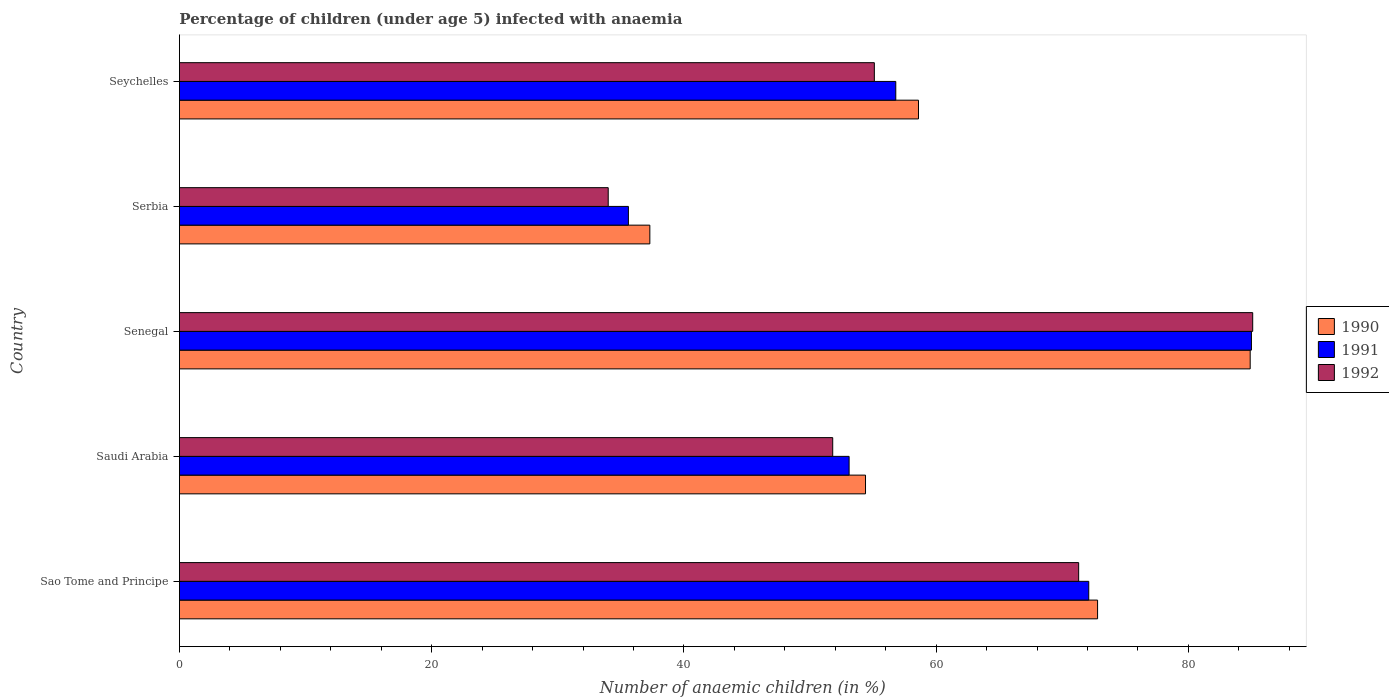How many different coloured bars are there?
Make the answer very short. 3. Are the number of bars per tick equal to the number of legend labels?
Keep it short and to the point. Yes. What is the label of the 3rd group of bars from the top?
Offer a very short reply. Senegal. What is the percentage of children infected with anaemia in in 1992 in Seychelles?
Give a very brief answer. 55.1. Across all countries, what is the maximum percentage of children infected with anaemia in in 1990?
Your answer should be compact. 84.9. Across all countries, what is the minimum percentage of children infected with anaemia in in 1990?
Keep it short and to the point. 37.3. In which country was the percentage of children infected with anaemia in in 1990 maximum?
Give a very brief answer. Senegal. In which country was the percentage of children infected with anaemia in in 1991 minimum?
Offer a very short reply. Serbia. What is the total percentage of children infected with anaemia in in 1992 in the graph?
Give a very brief answer. 297.3. What is the difference between the percentage of children infected with anaemia in in 1990 in Sao Tome and Principe and that in Senegal?
Provide a succinct answer. -12.1. What is the average percentage of children infected with anaemia in in 1990 per country?
Ensure brevity in your answer.  61.6. What is the difference between the percentage of children infected with anaemia in in 1991 and percentage of children infected with anaemia in in 1990 in Serbia?
Your answer should be very brief. -1.7. What is the ratio of the percentage of children infected with anaemia in in 1990 in Saudi Arabia to that in Serbia?
Provide a short and direct response. 1.46. What is the difference between the highest and the second highest percentage of children infected with anaemia in in 1990?
Your response must be concise. 12.1. What is the difference between the highest and the lowest percentage of children infected with anaemia in in 1990?
Provide a succinct answer. 47.6. What does the 3rd bar from the bottom in Sao Tome and Principe represents?
Your answer should be compact. 1992. Are all the bars in the graph horizontal?
Your answer should be very brief. Yes. Are the values on the major ticks of X-axis written in scientific E-notation?
Your answer should be very brief. No. Does the graph contain any zero values?
Provide a short and direct response. No. Where does the legend appear in the graph?
Provide a short and direct response. Center right. What is the title of the graph?
Your answer should be very brief. Percentage of children (under age 5) infected with anaemia. Does "1991" appear as one of the legend labels in the graph?
Offer a very short reply. Yes. What is the label or title of the X-axis?
Ensure brevity in your answer.  Number of anaemic children (in %). What is the label or title of the Y-axis?
Make the answer very short. Country. What is the Number of anaemic children (in %) in 1990 in Sao Tome and Principe?
Keep it short and to the point. 72.8. What is the Number of anaemic children (in %) of 1991 in Sao Tome and Principe?
Ensure brevity in your answer.  72.1. What is the Number of anaemic children (in %) in 1992 in Sao Tome and Principe?
Your response must be concise. 71.3. What is the Number of anaemic children (in %) of 1990 in Saudi Arabia?
Your answer should be very brief. 54.4. What is the Number of anaemic children (in %) in 1991 in Saudi Arabia?
Provide a succinct answer. 53.1. What is the Number of anaemic children (in %) in 1992 in Saudi Arabia?
Provide a short and direct response. 51.8. What is the Number of anaemic children (in %) in 1990 in Senegal?
Your answer should be very brief. 84.9. What is the Number of anaemic children (in %) of 1992 in Senegal?
Your answer should be very brief. 85.1. What is the Number of anaemic children (in %) in 1990 in Serbia?
Give a very brief answer. 37.3. What is the Number of anaemic children (in %) of 1991 in Serbia?
Offer a terse response. 35.6. What is the Number of anaemic children (in %) in 1990 in Seychelles?
Keep it short and to the point. 58.6. What is the Number of anaemic children (in %) in 1991 in Seychelles?
Your answer should be very brief. 56.8. What is the Number of anaemic children (in %) in 1992 in Seychelles?
Give a very brief answer. 55.1. Across all countries, what is the maximum Number of anaemic children (in %) of 1990?
Ensure brevity in your answer.  84.9. Across all countries, what is the maximum Number of anaemic children (in %) of 1992?
Give a very brief answer. 85.1. Across all countries, what is the minimum Number of anaemic children (in %) of 1990?
Provide a succinct answer. 37.3. Across all countries, what is the minimum Number of anaemic children (in %) of 1991?
Offer a terse response. 35.6. What is the total Number of anaemic children (in %) in 1990 in the graph?
Offer a very short reply. 308. What is the total Number of anaemic children (in %) of 1991 in the graph?
Provide a succinct answer. 302.6. What is the total Number of anaemic children (in %) in 1992 in the graph?
Ensure brevity in your answer.  297.3. What is the difference between the Number of anaemic children (in %) in 1991 in Sao Tome and Principe and that in Saudi Arabia?
Your answer should be compact. 19. What is the difference between the Number of anaemic children (in %) of 1990 in Sao Tome and Principe and that in Serbia?
Your answer should be compact. 35.5. What is the difference between the Number of anaemic children (in %) of 1991 in Sao Tome and Principe and that in Serbia?
Provide a succinct answer. 36.5. What is the difference between the Number of anaemic children (in %) of 1992 in Sao Tome and Principe and that in Serbia?
Offer a very short reply. 37.3. What is the difference between the Number of anaemic children (in %) of 1990 in Sao Tome and Principe and that in Seychelles?
Your answer should be compact. 14.2. What is the difference between the Number of anaemic children (in %) of 1991 in Sao Tome and Principe and that in Seychelles?
Your response must be concise. 15.3. What is the difference between the Number of anaemic children (in %) in 1990 in Saudi Arabia and that in Senegal?
Your response must be concise. -30.5. What is the difference between the Number of anaemic children (in %) of 1991 in Saudi Arabia and that in Senegal?
Your answer should be very brief. -31.9. What is the difference between the Number of anaemic children (in %) in 1992 in Saudi Arabia and that in Senegal?
Make the answer very short. -33.3. What is the difference between the Number of anaemic children (in %) in 1990 in Saudi Arabia and that in Serbia?
Your response must be concise. 17.1. What is the difference between the Number of anaemic children (in %) of 1991 in Saudi Arabia and that in Serbia?
Ensure brevity in your answer.  17.5. What is the difference between the Number of anaemic children (in %) of 1992 in Saudi Arabia and that in Serbia?
Your answer should be very brief. 17.8. What is the difference between the Number of anaemic children (in %) of 1990 in Saudi Arabia and that in Seychelles?
Ensure brevity in your answer.  -4.2. What is the difference between the Number of anaemic children (in %) in 1991 in Saudi Arabia and that in Seychelles?
Make the answer very short. -3.7. What is the difference between the Number of anaemic children (in %) in 1990 in Senegal and that in Serbia?
Offer a terse response. 47.6. What is the difference between the Number of anaemic children (in %) of 1991 in Senegal and that in Serbia?
Offer a very short reply. 49.4. What is the difference between the Number of anaemic children (in %) of 1992 in Senegal and that in Serbia?
Your answer should be very brief. 51.1. What is the difference between the Number of anaemic children (in %) in 1990 in Senegal and that in Seychelles?
Offer a very short reply. 26.3. What is the difference between the Number of anaemic children (in %) of 1991 in Senegal and that in Seychelles?
Ensure brevity in your answer.  28.2. What is the difference between the Number of anaemic children (in %) in 1992 in Senegal and that in Seychelles?
Keep it short and to the point. 30. What is the difference between the Number of anaemic children (in %) of 1990 in Serbia and that in Seychelles?
Give a very brief answer. -21.3. What is the difference between the Number of anaemic children (in %) of 1991 in Serbia and that in Seychelles?
Provide a succinct answer. -21.2. What is the difference between the Number of anaemic children (in %) in 1992 in Serbia and that in Seychelles?
Your answer should be compact. -21.1. What is the difference between the Number of anaemic children (in %) of 1991 in Sao Tome and Principe and the Number of anaemic children (in %) of 1992 in Saudi Arabia?
Make the answer very short. 20.3. What is the difference between the Number of anaemic children (in %) of 1990 in Sao Tome and Principe and the Number of anaemic children (in %) of 1992 in Senegal?
Provide a short and direct response. -12.3. What is the difference between the Number of anaemic children (in %) of 1990 in Sao Tome and Principe and the Number of anaemic children (in %) of 1991 in Serbia?
Provide a short and direct response. 37.2. What is the difference between the Number of anaemic children (in %) of 1990 in Sao Tome and Principe and the Number of anaemic children (in %) of 1992 in Serbia?
Keep it short and to the point. 38.8. What is the difference between the Number of anaemic children (in %) in 1991 in Sao Tome and Principe and the Number of anaemic children (in %) in 1992 in Serbia?
Keep it short and to the point. 38.1. What is the difference between the Number of anaemic children (in %) in 1990 in Sao Tome and Principe and the Number of anaemic children (in %) in 1991 in Seychelles?
Make the answer very short. 16. What is the difference between the Number of anaemic children (in %) in 1991 in Sao Tome and Principe and the Number of anaemic children (in %) in 1992 in Seychelles?
Keep it short and to the point. 17. What is the difference between the Number of anaemic children (in %) of 1990 in Saudi Arabia and the Number of anaemic children (in %) of 1991 in Senegal?
Keep it short and to the point. -30.6. What is the difference between the Number of anaemic children (in %) of 1990 in Saudi Arabia and the Number of anaemic children (in %) of 1992 in Senegal?
Your response must be concise. -30.7. What is the difference between the Number of anaemic children (in %) in 1991 in Saudi Arabia and the Number of anaemic children (in %) in 1992 in Senegal?
Keep it short and to the point. -32. What is the difference between the Number of anaemic children (in %) in 1990 in Saudi Arabia and the Number of anaemic children (in %) in 1992 in Serbia?
Give a very brief answer. 20.4. What is the difference between the Number of anaemic children (in %) of 1991 in Saudi Arabia and the Number of anaemic children (in %) of 1992 in Serbia?
Offer a terse response. 19.1. What is the difference between the Number of anaemic children (in %) of 1990 in Saudi Arabia and the Number of anaemic children (in %) of 1992 in Seychelles?
Make the answer very short. -0.7. What is the difference between the Number of anaemic children (in %) of 1991 in Saudi Arabia and the Number of anaemic children (in %) of 1992 in Seychelles?
Your answer should be compact. -2. What is the difference between the Number of anaemic children (in %) of 1990 in Senegal and the Number of anaemic children (in %) of 1991 in Serbia?
Offer a very short reply. 49.3. What is the difference between the Number of anaemic children (in %) in 1990 in Senegal and the Number of anaemic children (in %) in 1992 in Serbia?
Keep it short and to the point. 50.9. What is the difference between the Number of anaemic children (in %) of 1991 in Senegal and the Number of anaemic children (in %) of 1992 in Serbia?
Keep it short and to the point. 51. What is the difference between the Number of anaemic children (in %) in 1990 in Senegal and the Number of anaemic children (in %) in 1991 in Seychelles?
Your response must be concise. 28.1. What is the difference between the Number of anaemic children (in %) in 1990 in Senegal and the Number of anaemic children (in %) in 1992 in Seychelles?
Your response must be concise. 29.8. What is the difference between the Number of anaemic children (in %) in 1991 in Senegal and the Number of anaemic children (in %) in 1992 in Seychelles?
Offer a very short reply. 29.9. What is the difference between the Number of anaemic children (in %) in 1990 in Serbia and the Number of anaemic children (in %) in 1991 in Seychelles?
Provide a succinct answer. -19.5. What is the difference between the Number of anaemic children (in %) in 1990 in Serbia and the Number of anaemic children (in %) in 1992 in Seychelles?
Your answer should be compact. -17.8. What is the difference between the Number of anaemic children (in %) of 1991 in Serbia and the Number of anaemic children (in %) of 1992 in Seychelles?
Offer a very short reply. -19.5. What is the average Number of anaemic children (in %) of 1990 per country?
Keep it short and to the point. 61.6. What is the average Number of anaemic children (in %) in 1991 per country?
Make the answer very short. 60.52. What is the average Number of anaemic children (in %) of 1992 per country?
Ensure brevity in your answer.  59.46. What is the difference between the Number of anaemic children (in %) of 1990 and Number of anaemic children (in %) of 1991 in Sao Tome and Principe?
Give a very brief answer. 0.7. What is the difference between the Number of anaemic children (in %) of 1991 and Number of anaemic children (in %) of 1992 in Sao Tome and Principe?
Provide a short and direct response. 0.8. What is the difference between the Number of anaemic children (in %) in 1990 and Number of anaemic children (in %) in 1991 in Saudi Arabia?
Offer a terse response. 1.3. What is the difference between the Number of anaemic children (in %) in 1990 and Number of anaemic children (in %) in 1992 in Saudi Arabia?
Give a very brief answer. 2.6. What is the difference between the Number of anaemic children (in %) in 1991 and Number of anaemic children (in %) in 1992 in Senegal?
Your answer should be very brief. -0.1. What is the difference between the Number of anaemic children (in %) in 1990 and Number of anaemic children (in %) in 1992 in Serbia?
Provide a succinct answer. 3.3. What is the difference between the Number of anaemic children (in %) in 1990 and Number of anaemic children (in %) in 1992 in Seychelles?
Offer a very short reply. 3.5. What is the difference between the Number of anaemic children (in %) in 1991 and Number of anaemic children (in %) in 1992 in Seychelles?
Offer a terse response. 1.7. What is the ratio of the Number of anaemic children (in %) in 1990 in Sao Tome and Principe to that in Saudi Arabia?
Make the answer very short. 1.34. What is the ratio of the Number of anaemic children (in %) of 1991 in Sao Tome and Principe to that in Saudi Arabia?
Your response must be concise. 1.36. What is the ratio of the Number of anaemic children (in %) of 1992 in Sao Tome and Principe to that in Saudi Arabia?
Your answer should be very brief. 1.38. What is the ratio of the Number of anaemic children (in %) of 1990 in Sao Tome and Principe to that in Senegal?
Provide a succinct answer. 0.86. What is the ratio of the Number of anaemic children (in %) of 1991 in Sao Tome and Principe to that in Senegal?
Your answer should be compact. 0.85. What is the ratio of the Number of anaemic children (in %) of 1992 in Sao Tome and Principe to that in Senegal?
Give a very brief answer. 0.84. What is the ratio of the Number of anaemic children (in %) in 1990 in Sao Tome and Principe to that in Serbia?
Give a very brief answer. 1.95. What is the ratio of the Number of anaemic children (in %) in 1991 in Sao Tome and Principe to that in Serbia?
Ensure brevity in your answer.  2.03. What is the ratio of the Number of anaemic children (in %) in 1992 in Sao Tome and Principe to that in Serbia?
Provide a short and direct response. 2.1. What is the ratio of the Number of anaemic children (in %) in 1990 in Sao Tome and Principe to that in Seychelles?
Ensure brevity in your answer.  1.24. What is the ratio of the Number of anaemic children (in %) of 1991 in Sao Tome and Principe to that in Seychelles?
Make the answer very short. 1.27. What is the ratio of the Number of anaemic children (in %) in 1992 in Sao Tome and Principe to that in Seychelles?
Make the answer very short. 1.29. What is the ratio of the Number of anaemic children (in %) of 1990 in Saudi Arabia to that in Senegal?
Your answer should be compact. 0.64. What is the ratio of the Number of anaemic children (in %) of 1991 in Saudi Arabia to that in Senegal?
Provide a succinct answer. 0.62. What is the ratio of the Number of anaemic children (in %) in 1992 in Saudi Arabia to that in Senegal?
Offer a terse response. 0.61. What is the ratio of the Number of anaemic children (in %) in 1990 in Saudi Arabia to that in Serbia?
Ensure brevity in your answer.  1.46. What is the ratio of the Number of anaemic children (in %) in 1991 in Saudi Arabia to that in Serbia?
Make the answer very short. 1.49. What is the ratio of the Number of anaemic children (in %) in 1992 in Saudi Arabia to that in Serbia?
Offer a terse response. 1.52. What is the ratio of the Number of anaemic children (in %) of 1990 in Saudi Arabia to that in Seychelles?
Keep it short and to the point. 0.93. What is the ratio of the Number of anaemic children (in %) in 1991 in Saudi Arabia to that in Seychelles?
Your answer should be compact. 0.93. What is the ratio of the Number of anaemic children (in %) of 1992 in Saudi Arabia to that in Seychelles?
Offer a terse response. 0.94. What is the ratio of the Number of anaemic children (in %) of 1990 in Senegal to that in Serbia?
Offer a very short reply. 2.28. What is the ratio of the Number of anaemic children (in %) of 1991 in Senegal to that in Serbia?
Offer a terse response. 2.39. What is the ratio of the Number of anaemic children (in %) of 1992 in Senegal to that in Serbia?
Provide a short and direct response. 2.5. What is the ratio of the Number of anaemic children (in %) in 1990 in Senegal to that in Seychelles?
Your answer should be very brief. 1.45. What is the ratio of the Number of anaemic children (in %) of 1991 in Senegal to that in Seychelles?
Your answer should be compact. 1.5. What is the ratio of the Number of anaemic children (in %) of 1992 in Senegal to that in Seychelles?
Make the answer very short. 1.54. What is the ratio of the Number of anaemic children (in %) of 1990 in Serbia to that in Seychelles?
Offer a very short reply. 0.64. What is the ratio of the Number of anaemic children (in %) of 1991 in Serbia to that in Seychelles?
Your answer should be compact. 0.63. What is the ratio of the Number of anaemic children (in %) in 1992 in Serbia to that in Seychelles?
Offer a terse response. 0.62. What is the difference between the highest and the second highest Number of anaemic children (in %) in 1992?
Provide a short and direct response. 13.8. What is the difference between the highest and the lowest Number of anaemic children (in %) in 1990?
Give a very brief answer. 47.6. What is the difference between the highest and the lowest Number of anaemic children (in %) of 1991?
Your response must be concise. 49.4. What is the difference between the highest and the lowest Number of anaemic children (in %) in 1992?
Offer a very short reply. 51.1. 